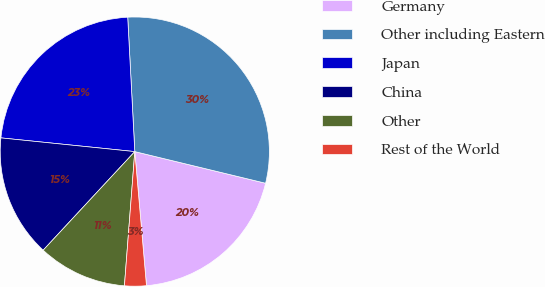Convert chart to OTSL. <chart><loc_0><loc_0><loc_500><loc_500><pie_chart><fcel>Germany<fcel>Other including Eastern<fcel>Japan<fcel>China<fcel>Other<fcel>Rest of the World<nl><fcel>19.84%<fcel>29.62%<fcel>22.54%<fcel>14.71%<fcel>10.69%<fcel>2.61%<nl></chart> 